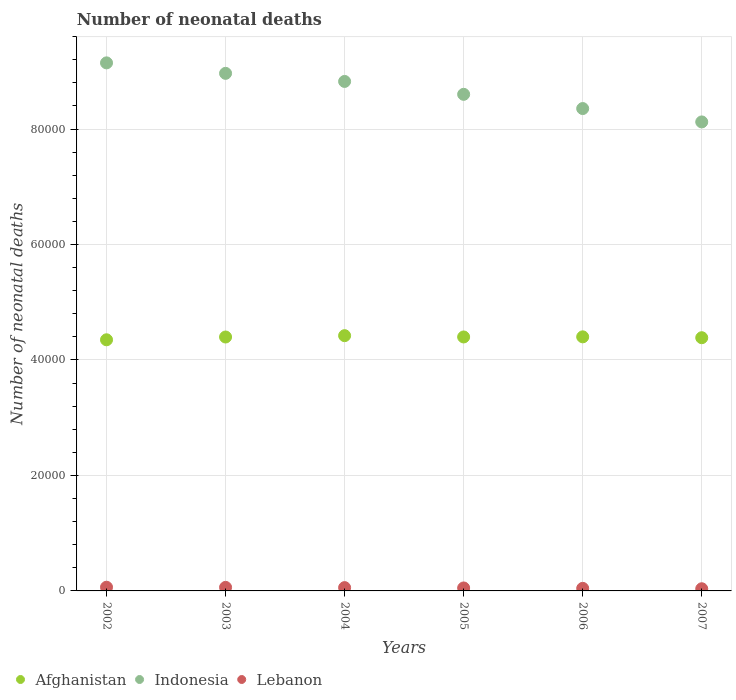How many different coloured dotlines are there?
Offer a terse response. 3. Is the number of dotlines equal to the number of legend labels?
Your answer should be very brief. Yes. What is the number of neonatal deaths in in Indonesia in 2003?
Offer a terse response. 8.96e+04. Across all years, what is the maximum number of neonatal deaths in in Lebanon?
Your response must be concise. 641. Across all years, what is the minimum number of neonatal deaths in in Indonesia?
Ensure brevity in your answer.  8.12e+04. In which year was the number of neonatal deaths in in Afghanistan maximum?
Provide a succinct answer. 2004. What is the total number of neonatal deaths in in Lebanon in the graph?
Offer a terse response. 3157. What is the difference between the number of neonatal deaths in in Indonesia in 2004 and that in 2007?
Provide a short and direct response. 7013. What is the difference between the number of neonatal deaths in in Lebanon in 2002 and the number of neonatal deaths in in Afghanistan in 2003?
Your answer should be very brief. -4.33e+04. What is the average number of neonatal deaths in in Indonesia per year?
Your answer should be compact. 8.67e+04. In the year 2007, what is the difference between the number of neonatal deaths in in Lebanon and number of neonatal deaths in in Indonesia?
Make the answer very short. -8.09e+04. What is the ratio of the number of neonatal deaths in in Lebanon in 2003 to that in 2004?
Your answer should be compact. 1.07. Is the number of neonatal deaths in in Indonesia in 2005 less than that in 2006?
Offer a terse response. No. What is the difference between the highest and the second highest number of neonatal deaths in in Indonesia?
Your answer should be very brief. 1815. What is the difference between the highest and the lowest number of neonatal deaths in in Indonesia?
Keep it short and to the point. 1.02e+04. In how many years, is the number of neonatal deaths in in Lebanon greater than the average number of neonatal deaths in in Lebanon taken over all years?
Offer a very short reply. 3. Is it the case that in every year, the sum of the number of neonatal deaths in in Indonesia and number of neonatal deaths in in Lebanon  is greater than the number of neonatal deaths in in Afghanistan?
Provide a short and direct response. Yes. Is the number of neonatal deaths in in Lebanon strictly less than the number of neonatal deaths in in Indonesia over the years?
Make the answer very short. Yes. How many dotlines are there?
Keep it short and to the point. 3. How many years are there in the graph?
Give a very brief answer. 6. What is the difference between two consecutive major ticks on the Y-axis?
Make the answer very short. 2.00e+04. Are the values on the major ticks of Y-axis written in scientific E-notation?
Provide a short and direct response. No. Does the graph contain any zero values?
Your answer should be compact. No. Does the graph contain grids?
Keep it short and to the point. Yes. Where does the legend appear in the graph?
Your response must be concise. Bottom left. How are the legend labels stacked?
Give a very brief answer. Horizontal. What is the title of the graph?
Make the answer very short. Number of neonatal deaths. What is the label or title of the X-axis?
Offer a terse response. Years. What is the label or title of the Y-axis?
Make the answer very short. Number of neonatal deaths. What is the Number of neonatal deaths of Afghanistan in 2002?
Offer a very short reply. 4.35e+04. What is the Number of neonatal deaths of Indonesia in 2002?
Keep it short and to the point. 9.15e+04. What is the Number of neonatal deaths in Lebanon in 2002?
Provide a short and direct response. 641. What is the Number of neonatal deaths of Afghanistan in 2003?
Your answer should be very brief. 4.40e+04. What is the Number of neonatal deaths of Indonesia in 2003?
Your answer should be very brief. 8.96e+04. What is the Number of neonatal deaths of Lebanon in 2003?
Offer a terse response. 613. What is the Number of neonatal deaths in Afghanistan in 2004?
Your answer should be compact. 4.42e+04. What is the Number of neonatal deaths in Indonesia in 2004?
Provide a short and direct response. 8.82e+04. What is the Number of neonatal deaths in Lebanon in 2004?
Ensure brevity in your answer.  572. What is the Number of neonatal deaths in Afghanistan in 2005?
Keep it short and to the point. 4.40e+04. What is the Number of neonatal deaths of Indonesia in 2005?
Keep it short and to the point. 8.60e+04. What is the Number of neonatal deaths of Lebanon in 2005?
Keep it short and to the point. 513. What is the Number of neonatal deaths of Afghanistan in 2006?
Your response must be concise. 4.40e+04. What is the Number of neonatal deaths in Indonesia in 2006?
Offer a terse response. 8.35e+04. What is the Number of neonatal deaths of Lebanon in 2006?
Your answer should be very brief. 443. What is the Number of neonatal deaths of Afghanistan in 2007?
Make the answer very short. 4.39e+04. What is the Number of neonatal deaths of Indonesia in 2007?
Your response must be concise. 8.12e+04. What is the Number of neonatal deaths in Lebanon in 2007?
Provide a short and direct response. 375. Across all years, what is the maximum Number of neonatal deaths in Afghanistan?
Make the answer very short. 4.42e+04. Across all years, what is the maximum Number of neonatal deaths of Indonesia?
Make the answer very short. 9.15e+04. Across all years, what is the maximum Number of neonatal deaths in Lebanon?
Ensure brevity in your answer.  641. Across all years, what is the minimum Number of neonatal deaths in Afghanistan?
Make the answer very short. 4.35e+04. Across all years, what is the minimum Number of neonatal deaths in Indonesia?
Offer a very short reply. 8.12e+04. Across all years, what is the minimum Number of neonatal deaths in Lebanon?
Offer a terse response. 375. What is the total Number of neonatal deaths in Afghanistan in the graph?
Offer a terse response. 2.64e+05. What is the total Number of neonatal deaths in Indonesia in the graph?
Give a very brief answer. 5.20e+05. What is the total Number of neonatal deaths of Lebanon in the graph?
Your answer should be compact. 3157. What is the difference between the Number of neonatal deaths in Afghanistan in 2002 and that in 2003?
Keep it short and to the point. -482. What is the difference between the Number of neonatal deaths in Indonesia in 2002 and that in 2003?
Your response must be concise. 1815. What is the difference between the Number of neonatal deaths in Lebanon in 2002 and that in 2003?
Provide a short and direct response. 28. What is the difference between the Number of neonatal deaths of Afghanistan in 2002 and that in 2004?
Provide a succinct answer. -716. What is the difference between the Number of neonatal deaths of Indonesia in 2002 and that in 2004?
Keep it short and to the point. 3216. What is the difference between the Number of neonatal deaths of Afghanistan in 2002 and that in 2005?
Make the answer very short. -490. What is the difference between the Number of neonatal deaths in Indonesia in 2002 and that in 2005?
Keep it short and to the point. 5449. What is the difference between the Number of neonatal deaths of Lebanon in 2002 and that in 2005?
Make the answer very short. 128. What is the difference between the Number of neonatal deaths of Afghanistan in 2002 and that in 2006?
Your answer should be very brief. -510. What is the difference between the Number of neonatal deaths of Indonesia in 2002 and that in 2006?
Ensure brevity in your answer.  7913. What is the difference between the Number of neonatal deaths in Lebanon in 2002 and that in 2006?
Your response must be concise. 198. What is the difference between the Number of neonatal deaths in Afghanistan in 2002 and that in 2007?
Ensure brevity in your answer.  -359. What is the difference between the Number of neonatal deaths in Indonesia in 2002 and that in 2007?
Ensure brevity in your answer.  1.02e+04. What is the difference between the Number of neonatal deaths in Lebanon in 2002 and that in 2007?
Offer a terse response. 266. What is the difference between the Number of neonatal deaths in Afghanistan in 2003 and that in 2004?
Provide a succinct answer. -234. What is the difference between the Number of neonatal deaths in Indonesia in 2003 and that in 2004?
Provide a succinct answer. 1401. What is the difference between the Number of neonatal deaths of Lebanon in 2003 and that in 2004?
Offer a terse response. 41. What is the difference between the Number of neonatal deaths of Afghanistan in 2003 and that in 2005?
Provide a succinct answer. -8. What is the difference between the Number of neonatal deaths of Indonesia in 2003 and that in 2005?
Ensure brevity in your answer.  3634. What is the difference between the Number of neonatal deaths in Lebanon in 2003 and that in 2005?
Your response must be concise. 100. What is the difference between the Number of neonatal deaths in Indonesia in 2003 and that in 2006?
Provide a succinct answer. 6098. What is the difference between the Number of neonatal deaths in Lebanon in 2003 and that in 2006?
Your answer should be compact. 170. What is the difference between the Number of neonatal deaths in Afghanistan in 2003 and that in 2007?
Make the answer very short. 123. What is the difference between the Number of neonatal deaths in Indonesia in 2003 and that in 2007?
Make the answer very short. 8414. What is the difference between the Number of neonatal deaths in Lebanon in 2003 and that in 2007?
Give a very brief answer. 238. What is the difference between the Number of neonatal deaths of Afghanistan in 2004 and that in 2005?
Give a very brief answer. 226. What is the difference between the Number of neonatal deaths in Indonesia in 2004 and that in 2005?
Your answer should be very brief. 2233. What is the difference between the Number of neonatal deaths in Lebanon in 2004 and that in 2005?
Offer a terse response. 59. What is the difference between the Number of neonatal deaths in Afghanistan in 2004 and that in 2006?
Keep it short and to the point. 206. What is the difference between the Number of neonatal deaths in Indonesia in 2004 and that in 2006?
Keep it short and to the point. 4697. What is the difference between the Number of neonatal deaths in Lebanon in 2004 and that in 2006?
Offer a very short reply. 129. What is the difference between the Number of neonatal deaths of Afghanistan in 2004 and that in 2007?
Make the answer very short. 357. What is the difference between the Number of neonatal deaths in Indonesia in 2004 and that in 2007?
Give a very brief answer. 7013. What is the difference between the Number of neonatal deaths in Lebanon in 2004 and that in 2007?
Make the answer very short. 197. What is the difference between the Number of neonatal deaths in Indonesia in 2005 and that in 2006?
Offer a terse response. 2464. What is the difference between the Number of neonatal deaths in Lebanon in 2005 and that in 2006?
Your answer should be very brief. 70. What is the difference between the Number of neonatal deaths of Afghanistan in 2005 and that in 2007?
Your answer should be compact. 131. What is the difference between the Number of neonatal deaths of Indonesia in 2005 and that in 2007?
Provide a succinct answer. 4780. What is the difference between the Number of neonatal deaths of Lebanon in 2005 and that in 2007?
Give a very brief answer. 138. What is the difference between the Number of neonatal deaths of Afghanistan in 2006 and that in 2007?
Make the answer very short. 151. What is the difference between the Number of neonatal deaths in Indonesia in 2006 and that in 2007?
Your answer should be very brief. 2316. What is the difference between the Number of neonatal deaths of Lebanon in 2006 and that in 2007?
Provide a short and direct response. 68. What is the difference between the Number of neonatal deaths of Afghanistan in 2002 and the Number of neonatal deaths of Indonesia in 2003?
Ensure brevity in your answer.  -4.61e+04. What is the difference between the Number of neonatal deaths of Afghanistan in 2002 and the Number of neonatal deaths of Lebanon in 2003?
Provide a succinct answer. 4.29e+04. What is the difference between the Number of neonatal deaths in Indonesia in 2002 and the Number of neonatal deaths in Lebanon in 2003?
Offer a terse response. 9.08e+04. What is the difference between the Number of neonatal deaths in Afghanistan in 2002 and the Number of neonatal deaths in Indonesia in 2004?
Provide a short and direct response. -4.47e+04. What is the difference between the Number of neonatal deaths in Afghanistan in 2002 and the Number of neonatal deaths in Lebanon in 2004?
Ensure brevity in your answer.  4.29e+04. What is the difference between the Number of neonatal deaths in Indonesia in 2002 and the Number of neonatal deaths in Lebanon in 2004?
Offer a very short reply. 9.09e+04. What is the difference between the Number of neonatal deaths in Afghanistan in 2002 and the Number of neonatal deaths in Indonesia in 2005?
Ensure brevity in your answer.  -4.25e+04. What is the difference between the Number of neonatal deaths in Afghanistan in 2002 and the Number of neonatal deaths in Lebanon in 2005?
Your answer should be compact. 4.30e+04. What is the difference between the Number of neonatal deaths in Indonesia in 2002 and the Number of neonatal deaths in Lebanon in 2005?
Your answer should be very brief. 9.09e+04. What is the difference between the Number of neonatal deaths in Afghanistan in 2002 and the Number of neonatal deaths in Indonesia in 2006?
Offer a very short reply. -4.01e+04. What is the difference between the Number of neonatal deaths in Afghanistan in 2002 and the Number of neonatal deaths in Lebanon in 2006?
Your response must be concise. 4.31e+04. What is the difference between the Number of neonatal deaths of Indonesia in 2002 and the Number of neonatal deaths of Lebanon in 2006?
Offer a very short reply. 9.10e+04. What is the difference between the Number of neonatal deaths in Afghanistan in 2002 and the Number of neonatal deaths in Indonesia in 2007?
Provide a succinct answer. -3.77e+04. What is the difference between the Number of neonatal deaths of Afghanistan in 2002 and the Number of neonatal deaths of Lebanon in 2007?
Give a very brief answer. 4.31e+04. What is the difference between the Number of neonatal deaths in Indonesia in 2002 and the Number of neonatal deaths in Lebanon in 2007?
Offer a very short reply. 9.11e+04. What is the difference between the Number of neonatal deaths in Afghanistan in 2003 and the Number of neonatal deaths in Indonesia in 2004?
Your answer should be compact. -4.43e+04. What is the difference between the Number of neonatal deaths of Afghanistan in 2003 and the Number of neonatal deaths of Lebanon in 2004?
Offer a very short reply. 4.34e+04. What is the difference between the Number of neonatal deaths of Indonesia in 2003 and the Number of neonatal deaths of Lebanon in 2004?
Your response must be concise. 8.91e+04. What is the difference between the Number of neonatal deaths in Afghanistan in 2003 and the Number of neonatal deaths in Indonesia in 2005?
Offer a very short reply. -4.20e+04. What is the difference between the Number of neonatal deaths of Afghanistan in 2003 and the Number of neonatal deaths of Lebanon in 2005?
Give a very brief answer. 4.35e+04. What is the difference between the Number of neonatal deaths in Indonesia in 2003 and the Number of neonatal deaths in Lebanon in 2005?
Your response must be concise. 8.91e+04. What is the difference between the Number of neonatal deaths in Afghanistan in 2003 and the Number of neonatal deaths in Indonesia in 2006?
Keep it short and to the point. -3.96e+04. What is the difference between the Number of neonatal deaths in Afghanistan in 2003 and the Number of neonatal deaths in Lebanon in 2006?
Your answer should be very brief. 4.35e+04. What is the difference between the Number of neonatal deaths in Indonesia in 2003 and the Number of neonatal deaths in Lebanon in 2006?
Your answer should be very brief. 8.92e+04. What is the difference between the Number of neonatal deaths of Afghanistan in 2003 and the Number of neonatal deaths of Indonesia in 2007?
Ensure brevity in your answer.  -3.73e+04. What is the difference between the Number of neonatal deaths of Afghanistan in 2003 and the Number of neonatal deaths of Lebanon in 2007?
Provide a succinct answer. 4.36e+04. What is the difference between the Number of neonatal deaths of Indonesia in 2003 and the Number of neonatal deaths of Lebanon in 2007?
Provide a succinct answer. 8.93e+04. What is the difference between the Number of neonatal deaths in Afghanistan in 2004 and the Number of neonatal deaths in Indonesia in 2005?
Ensure brevity in your answer.  -4.18e+04. What is the difference between the Number of neonatal deaths of Afghanistan in 2004 and the Number of neonatal deaths of Lebanon in 2005?
Ensure brevity in your answer.  4.37e+04. What is the difference between the Number of neonatal deaths in Indonesia in 2004 and the Number of neonatal deaths in Lebanon in 2005?
Your answer should be very brief. 8.77e+04. What is the difference between the Number of neonatal deaths in Afghanistan in 2004 and the Number of neonatal deaths in Indonesia in 2006?
Offer a very short reply. -3.93e+04. What is the difference between the Number of neonatal deaths in Afghanistan in 2004 and the Number of neonatal deaths in Lebanon in 2006?
Keep it short and to the point. 4.38e+04. What is the difference between the Number of neonatal deaths of Indonesia in 2004 and the Number of neonatal deaths of Lebanon in 2006?
Provide a short and direct response. 8.78e+04. What is the difference between the Number of neonatal deaths in Afghanistan in 2004 and the Number of neonatal deaths in Indonesia in 2007?
Offer a terse response. -3.70e+04. What is the difference between the Number of neonatal deaths in Afghanistan in 2004 and the Number of neonatal deaths in Lebanon in 2007?
Keep it short and to the point. 4.38e+04. What is the difference between the Number of neonatal deaths in Indonesia in 2004 and the Number of neonatal deaths in Lebanon in 2007?
Offer a very short reply. 8.79e+04. What is the difference between the Number of neonatal deaths in Afghanistan in 2005 and the Number of neonatal deaths in Indonesia in 2006?
Offer a very short reply. -3.96e+04. What is the difference between the Number of neonatal deaths of Afghanistan in 2005 and the Number of neonatal deaths of Lebanon in 2006?
Your answer should be very brief. 4.35e+04. What is the difference between the Number of neonatal deaths of Indonesia in 2005 and the Number of neonatal deaths of Lebanon in 2006?
Your answer should be very brief. 8.56e+04. What is the difference between the Number of neonatal deaths in Afghanistan in 2005 and the Number of neonatal deaths in Indonesia in 2007?
Give a very brief answer. -3.72e+04. What is the difference between the Number of neonatal deaths of Afghanistan in 2005 and the Number of neonatal deaths of Lebanon in 2007?
Ensure brevity in your answer.  4.36e+04. What is the difference between the Number of neonatal deaths in Indonesia in 2005 and the Number of neonatal deaths in Lebanon in 2007?
Offer a very short reply. 8.56e+04. What is the difference between the Number of neonatal deaths in Afghanistan in 2006 and the Number of neonatal deaths in Indonesia in 2007?
Provide a short and direct response. -3.72e+04. What is the difference between the Number of neonatal deaths in Afghanistan in 2006 and the Number of neonatal deaths in Lebanon in 2007?
Make the answer very short. 4.36e+04. What is the difference between the Number of neonatal deaths in Indonesia in 2006 and the Number of neonatal deaths in Lebanon in 2007?
Provide a short and direct response. 8.32e+04. What is the average Number of neonatal deaths of Afghanistan per year?
Your answer should be very brief. 4.39e+04. What is the average Number of neonatal deaths in Indonesia per year?
Ensure brevity in your answer.  8.67e+04. What is the average Number of neonatal deaths of Lebanon per year?
Your response must be concise. 526.17. In the year 2002, what is the difference between the Number of neonatal deaths in Afghanistan and Number of neonatal deaths in Indonesia?
Make the answer very short. -4.80e+04. In the year 2002, what is the difference between the Number of neonatal deaths in Afghanistan and Number of neonatal deaths in Lebanon?
Your answer should be very brief. 4.29e+04. In the year 2002, what is the difference between the Number of neonatal deaths in Indonesia and Number of neonatal deaths in Lebanon?
Offer a terse response. 9.08e+04. In the year 2003, what is the difference between the Number of neonatal deaths in Afghanistan and Number of neonatal deaths in Indonesia?
Provide a short and direct response. -4.57e+04. In the year 2003, what is the difference between the Number of neonatal deaths of Afghanistan and Number of neonatal deaths of Lebanon?
Provide a succinct answer. 4.34e+04. In the year 2003, what is the difference between the Number of neonatal deaths of Indonesia and Number of neonatal deaths of Lebanon?
Your answer should be compact. 8.90e+04. In the year 2004, what is the difference between the Number of neonatal deaths in Afghanistan and Number of neonatal deaths in Indonesia?
Keep it short and to the point. -4.40e+04. In the year 2004, what is the difference between the Number of neonatal deaths in Afghanistan and Number of neonatal deaths in Lebanon?
Make the answer very short. 4.36e+04. In the year 2004, what is the difference between the Number of neonatal deaths of Indonesia and Number of neonatal deaths of Lebanon?
Provide a succinct answer. 8.77e+04. In the year 2005, what is the difference between the Number of neonatal deaths in Afghanistan and Number of neonatal deaths in Indonesia?
Ensure brevity in your answer.  -4.20e+04. In the year 2005, what is the difference between the Number of neonatal deaths of Afghanistan and Number of neonatal deaths of Lebanon?
Your answer should be very brief. 4.35e+04. In the year 2005, what is the difference between the Number of neonatal deaths in Indonesia and Number of neonatal deaths in Lebanon?
Provide a succinct answer. 8.55e+04. In the year 2006, what is the difference between the Number of neonatal deaths of Afghanistan and Number of neonatal deaths of Indonesia?
Your answer should be compact. -3.95e+04. In the year 2006, what is the difference between the Number of neonatal deaths of Afghanistan and Number of neonatal deaths of Lebanon?
Offer a very short reply. 4.36e+04. In the year 2006, what is the difference between the Number of neonatal deaths of Indonesia and Number of neonatal deaths of Lebanon?
Your response must be concise. 8.31e+04. In the year 2007, what is the difference between the Number of neonatal deaths in Afghanistan and Number of neonatal deaths in Indonesia?
Offer a very short reply. -3.74e+04. In the year 2007, what is the difference between the Number of neonatal deaths in Afghanistan and Number of neonatal deaths in Lebanon?
Ensure brevity in your answer.  4.35e+04. In the year 2007, what is the difference between the Number of neonatal deaths in Indonesia and Number of neonatal deaths in Lebanon?
Your response must be concise. 8.09e+04. What is the ratio of the Number of neonatal deaths of Indonesia in 2002 to that in 2003?
Your answer should be compact. 1.02. What is the ratio of the Number of neonatal deaths in Lebanon in 2002 to that in 2003?
Your answer should be very brief. 1.05. What is the ratio of the Number of neonatal deaths of Afghanistan in 2002 to that in 2004?
Ensure brevity in your answer.  0.98. What is the ratio of the Number of neonatal deaths of Indonesia in 2002 to that in 2004?
Your answer should be compact. 1.04. What is the ratio of the Number of neonatal deaths of Lebanon in 2002 to that in 2004?
Give a very brief answer. 1.12. What is the ratio of the Number of neonatal deaths of Afghanistan in 2002 to that in 2005?
Keep it short and to the point. 0.99. What is the ratio of the Number of neonatal deaths in Indonesia in 2002 to that in 2005?
Give a very brief answer. 1.06. What is the ratio of the Number of neonatal deaths of Lebanon in 2002 to that in 2005?
Your response must be concise. 1.25. What is the ratio of the Number of neonatal deaths of Afghanistan in 2002 to that in 2006?
Make the answer very short. 0.99. What is the ratio of the Number of neonatal deaths in Indonesia in 2002 to that in 2006?
Your answer should be compact. 1.09. What is the ratio of the Number of neonatal deaths in Lebanon in 2002 to that in 2006?
Provide a succinct answer. 1.45. What is the ratio of the Number of neonatal deaths of Afghanistan in 2002 to that in 2007?
Keep it short and to the point. 0.99. What is the ratio of the Number of neonatal deaths in Indonesia in 2002 to that in 2007?
Provide a short and direct response. 1.13. What is the ratio of the Number of neonatal deaths of Lebanon in 2002 to that in 2007?
Provide a succinct answer. 1.71. What is the ratio of the Number of neonatal deaths of Afghanistan in 2003 to that in 2004?
Make the answer very short. 0.99. What is the ratio of the Number of neonatal deaths of Indonesia in 2003 to that in 2004?
Offer a terse response. 1.02. What is the ratio of the Number of neonatal deaths in Lebanon in 2003 to that in 2004?
Keep it short and to the point. 1.07. What is the ratio of the Number of neonatal deaths in Indonesia in 2003 to that in 2005?
Your response must be concise. 1.04. What is the ratio of the Number of neonatal deaths of Lebanon in 2003 to that in 2005?
Provide a short and direct response. 1.19. What is the ratio of the Number of neonatal deaths of Afghanistan in 2003 to that in 2006?
Provide a short and direct response. 1. What is the ratio of the Number of neonatal deaths in Indonesia in 2003 to that in 2006?
Provide a short and direct response. 1.07. What is the ratio of the Number of neonatal deaths of Lebanon in 2003 to that in 2006?
Keep it short and to the point. 1.38. What is the ratio of the Number of neonatal deaths of Indonesia in 2003 to that in 2007?
Your answer should be compact. 1.1. What is the ratio of the Number of neonatal deaths of Lebanon in 2003 to that in 2007?
Your answer should be compact. 1.63. What is the ratio of the Number of neonatal deaths of Lebanon in 2004 to that in 2005?
Your answer should be compact. 1.11. What is the ratio of the Number of neonatal deaths of Afghanistan in 2004 to that in 2006?
Make the answer very short. 1. What is the ratio of the Number of neonatal deaths of Indonesia in 2004 to that in 2006?
Your answer should be very brief. 1.06. What is the ratio of the Number of neonatal deaths of Lebanon in 2004 to that in 2006?
Offer a very short reply. 1.29. What is the ratio of the Number of neonatal deaths of Indonesia in 2004 to that in 2007?
Your answer should be very brief. 1.09. What is the ratio of the Number of neonatal deaths in Lebanon in 2004 to that in 2007?
Offer a very short reply. 1.53. What is the ratio of the Number of neonatal deaths in Afghanistan in 2005 to that in 2006?
Make the answer very short. 1. What is the ratio of the Number of neonatal deaths of Indonesia in 2005 to that in 2006?
Your answer should be very brief. 1.03. What is the ratio of the Number of neonatal deaths in Lebanon in 2005 to that in 2006?
Your answer should be very brief. 1.16. What is the ratio of the Number of neonatal deaths in Afghanistan in 2005 to that in 2007?
Your response must be concise. 1. What is the ratio of the Number of neonatal deaths of Indonesia in 2005 to that in 2007?
Offer a terse response. 1.06. What is the ratio of the Number of neonatal deaths in Lebanon in 2005 to that in 2007?
Provide a succinct answer. 1.37. What is the ratio of the Number of neonatal deaths in Indonesia in 2006 to that in 2007?
Provide a succinct answer. 1.03. What is the ratio of the Number of neonatal deaths of Lebanon in 2006 to that in 2007?
Your answer should be compact. 1.18. What is the difference between the highest and the second highest Number of neonatal deaths in Afghanistan?
Your answer should be compact. 206. What is the difference between the highest and the second highest Number of neonatal deaths of Indonesia?
Your answer should be very brief. 1815. What is the difference between the highest and the lowest Number of neonatal deaths of Afghanistan?
Your answer should be compact. 716. What is the difference between the highest and the lowest Number of neonatal deaths of Indonesia?
Offer a terse response. 1.02e+04. What is the difference between the highest and the lowest Number of neonatal deaths in Lebanon?
Provide a succinct answer. 266. 